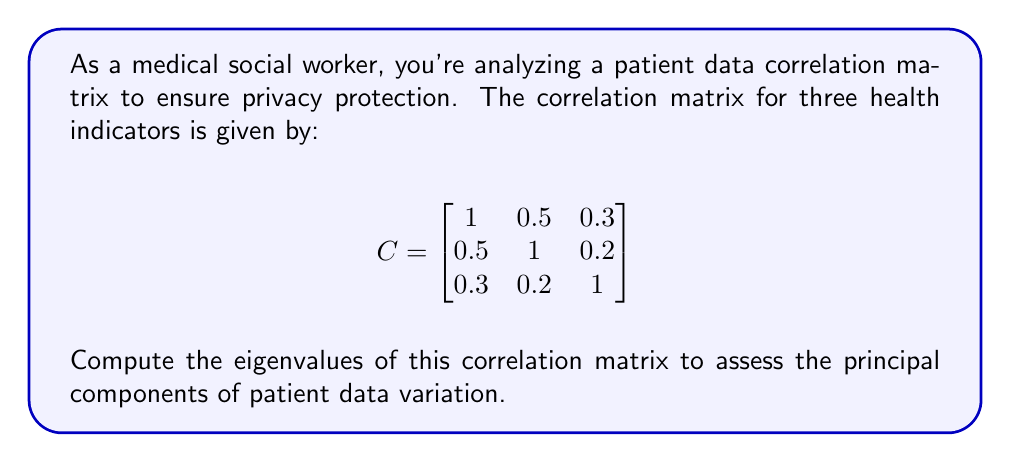Teach me how to tackle this problem. To compute the eigenvalues of the correlation matrix C, we need to solve the characteristic equation:

$$\det(C - \lambda I) = 0$$

where $\lambda$ represents the eigenvalues and I is the 3x3 identity matrix.

Step 1: Set up the characteristic equation:

$$
\begin{vmatrix}
1-\lambda & 0.5 & 0.3 \\
0.5 & 1-\lambda & 0.2 \\
0.3 & 0.2 & 1-\lambda
\end{vmatrix} = 0
$$

Step 2: Expand the determinant:

$$(1-\lambda)[(1-\lambda)(1-\lambda) - 0.04] - 0.5[0.5(1-\lambda) - 0.06] + 0.3[0.1 - 0.5(1-\lambda)] = 0$$

Step 3: Simplify:

$$(1-\lambda)[(1-\lambda)^2 - 0.04] - 0.25(1-\lambda) + 0.03 + 0.03 - 0.15(1-\lambda) = 0$$
$$(1-\lambda)^3 - 0.04(1-\lambda) - 0.25(1-\lambda) - 0.15(1-\lambda) + 0.06 = 0$$
$$(1-\lambda)^3 - 0.44(1-\lambda) + 0.06 = 0$$

Step 4: Substitute $x = 1-\lambda$:

$$x^3 - 0.44x + 0.06 = 0$$

Step 5: Solve this cubic equation. The roots of this equation are approximately:

$$x_1 \approx 0.7697$$
$$x_2 \approx -0.5850$$
$$x_3 \approx 0.2153$$

Step 6: Convert back to $\lambda$ values:

$$\lambda_1 = 1 - x_1 \approx 0.2303$$
$$\lambda_2 = 1 - x_2 \approx 1.5850$$
$$\lambda_3 = 1 - x_3 \approx 0.7847$$
Answer: $\lambda_1 \approx 0.2303$, $\lambda_2 \approx 1.5850$, $\lambda_3 \approx 0.7847$ 